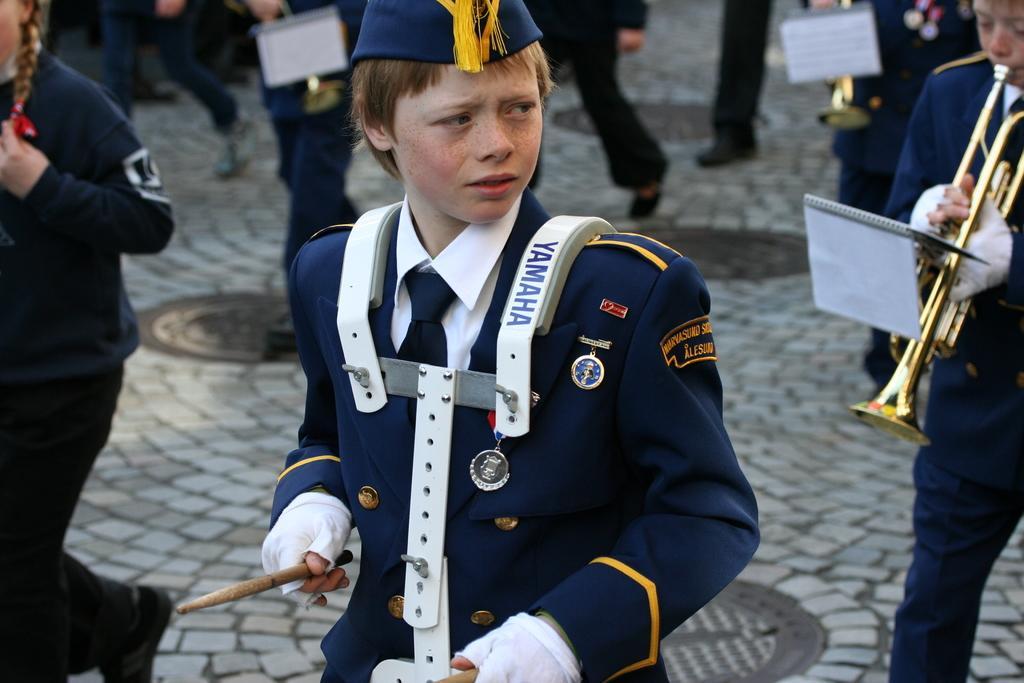In one or two sentences, can you explain what this image depicts? In this image we can see a few people are playing musical instruments, there are books, also the background is blurred. 